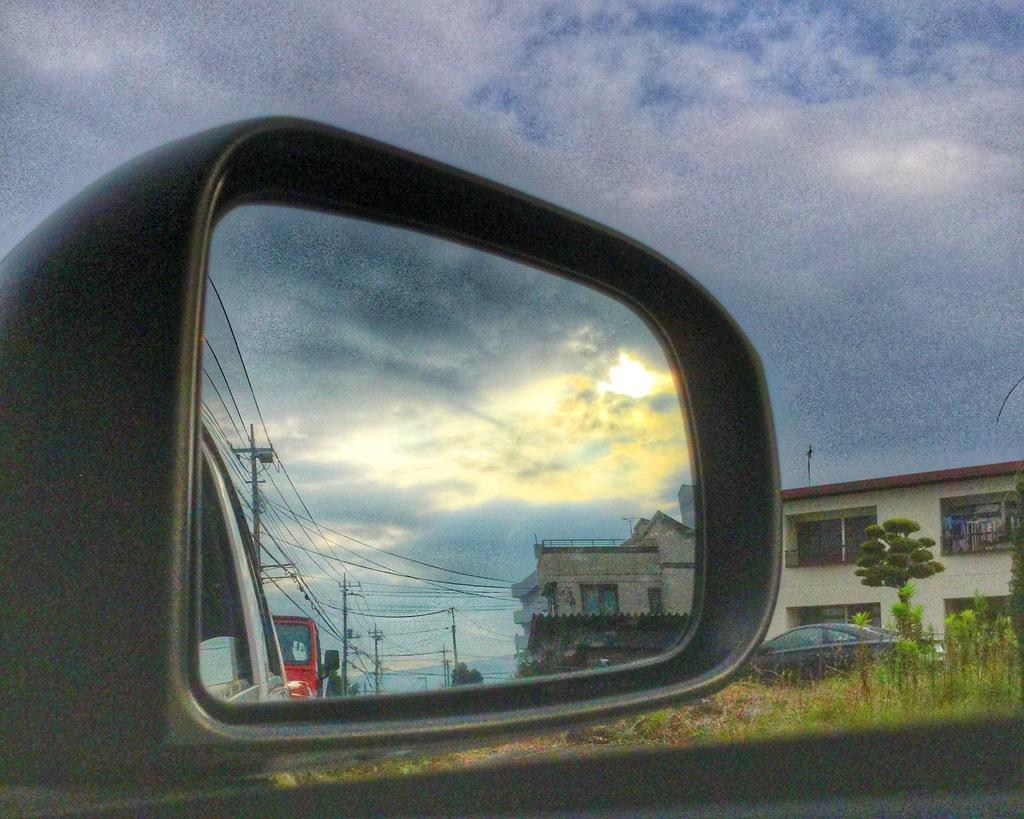What type of structure is visible in the image? There is a house in the image. What features can be seen on the house? The house has windows. What type of vegetation is present in the image? There are plants and trees in the image. What can be seen in the side mirror of a vehicle in the image? There are reflections of houses, vehicles, poles, and wires, as well as the sky, in the side mirror of a vehicle. What type of garden can be seen in the image? There is no garden present in the image. How many pizzas are visible in the image? There are no pizzas present in the image. 